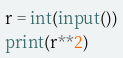<code> <loc_0><loc_0><loc_500><loc_500><_Python_>r = int(input())
print(r**2)</code> 